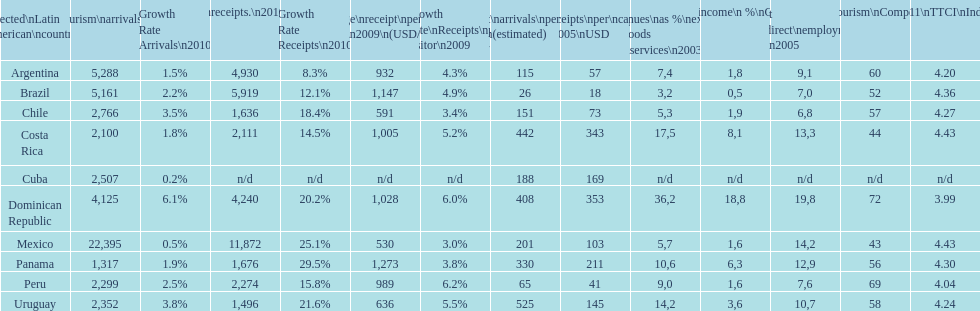Which latin american nation had the highest amount of tourist visits in 2010? Mexico. 